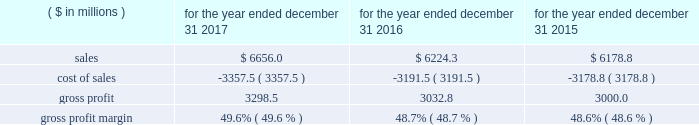2022 higher 2017 sales volumes , incremental year-over-year cost savings associated with restructuring and productivity improvement initiatives , costs associated with various growth investments made in 2016 and changes in currency exchange rates , partially offset by incremental year-over-year costs associated with various product development and sales and marketing growth investments : 60 basis points year-over-year operating profit margin comparisons were unfavorably impacted by : 2022 the incremental year-over-year net dilutive effect of acquired businesses : 20 basis points 2016 compared to 2015 year-over-year price increases in the segment contributed 0.3% ( 0.3 % ) to sales growth during 2016 as compared to 2015 and are reflected as a component of the change in sales from existing businesses .
Sales from existing businesses in the segment 2019s transportation technologies businesses grew at a high-single digit rate during 2016 as compared to 2015 , due primarily to strong demand for dispenser , payment and point-of-sale systems , environmental compliance products as well as vehicle and fleet management products , partly offset by weaker year-over-year demand for compressed natural gas products .
As expected , beginning in the second half of 2016 , the business began to experience reduced emv-related demand for indoor point-of-sale solutions , as customers had largely upgraded to products that support indoor emv requirements in the prior year in response to the indoor liability shift .
However , demand increased on a year-over-year basis for dispensers and payment systems as customers in the united states continued to upgrade equipment driven primarily by the emv deadlines related to outdoor payment systems .
Geographically , sales from existing businesses continued to increase on a year-over-year basis in the united states and to a lesser extent in asia and western europe .
Sales from existing businesses in the segment 2019s automation & specialty components business declined at a low-single digit rate during 2016 as compared to 2015 .
The businesses experienced sequential year-over-year improvement in demand during the second half of 2016 as compared to the first half of 2016 .
During 2016 , year-over-year demand declined for engine retarder products due primarily to weakness in the north american heavy-truck market , partly offset by strong growth in china and europe .
In addition , year-over-year demand declined in certain medical and defense related end markets which were partly offset by increased year-over-year demand for industrial automation products particularly in china .
Geographically , sales from existing businesses in the segment 2019s automation & specialty components businesses declined in north america , partly offset by growth in western europe and china .
Sales from existing businesses in the segment 2019s franchise distribution business grew at a mid-single digit rate during 2016 , as compared to 2015 , due primarily to continued net increases in franchisees as well as continued growth in demand for professional tool products and tool storage products , primarily in the united states .
This growth was partly offset by year- over-year declines in wheel service equipment sales during 2016 .
Operating profit margins increased 70 basis points during 2016 as compared to 2015 .
The following factors favorably impacted year-over-year operating profit margin comparisons : 2022 higher 2016 sales volumes , pricing improvements , incremental year-over-year cost savings associated with restructuring and productivity improvement initiatives and the incrementally favorable impact of the impairment of certain tradenames used in the segment in 2015 and 2016 , net of costs associated with various growth investments , product development and sales and marketing growth investments , higher year-over-year costs associated with restructuring actions and changes in currency exchange rates : 65 basis points 2022 the incremental net accretive effect in 2016 of acquired businesses : 5 basis points cost of sales and gross profit .
The year-over-year increase in cost of sales during 2017 as compared to 2016 is due primarily to the impact of higher year- over-year sales volumes and changes in currency exchange rates partly offset by incremental year-over-year cost savings .
What was the percentage change in sales from 2015 to 2016? 
Computations: ((6224.3 - 6178.8) / 6178.8)
Answer: 0.00736. 